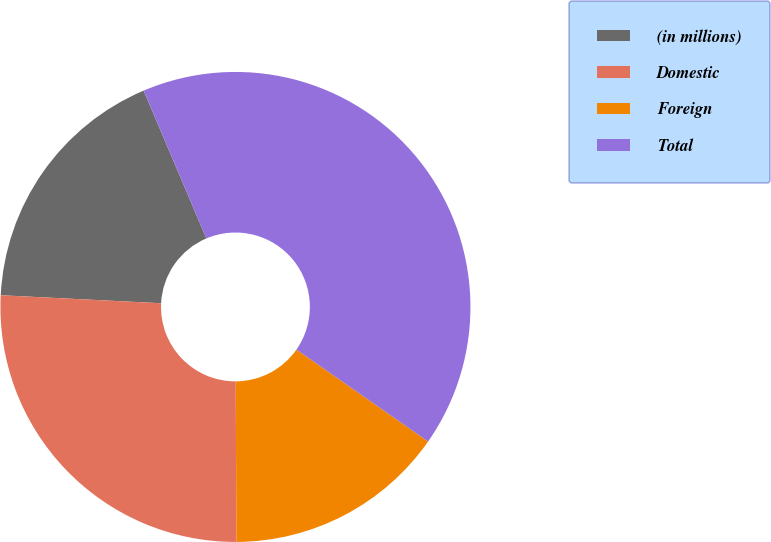Convert chart. <chart><loc_0><loc_0><loc_500><loc_500><pie_chart><fcel>(in millions)<fcel>Domestic<fcel>Foreign<fcel>Total<nl><fcel>17.82%<fcel>25.86%<fcel>15.23%<fcel>41.09%<nl></chart> 